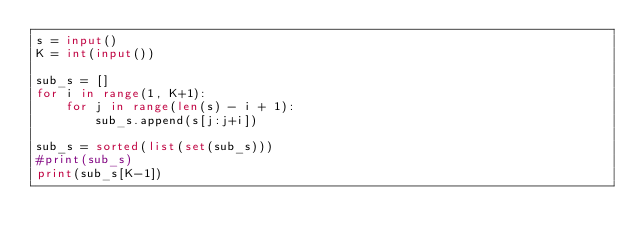<code> <loc_0><loc_0><loc_500><loc_500><_Python_>s = input()
K = int(input())
 
sub_s = []
for i in range(1, K+1):
    for j in range(len(s) - i + 1):
        sub_s.append(s[j:j+i])
 
sub_s = sorted(list(set(sub_s)))        
#print(sub_s)
print(sub_s[K-1])</code> 